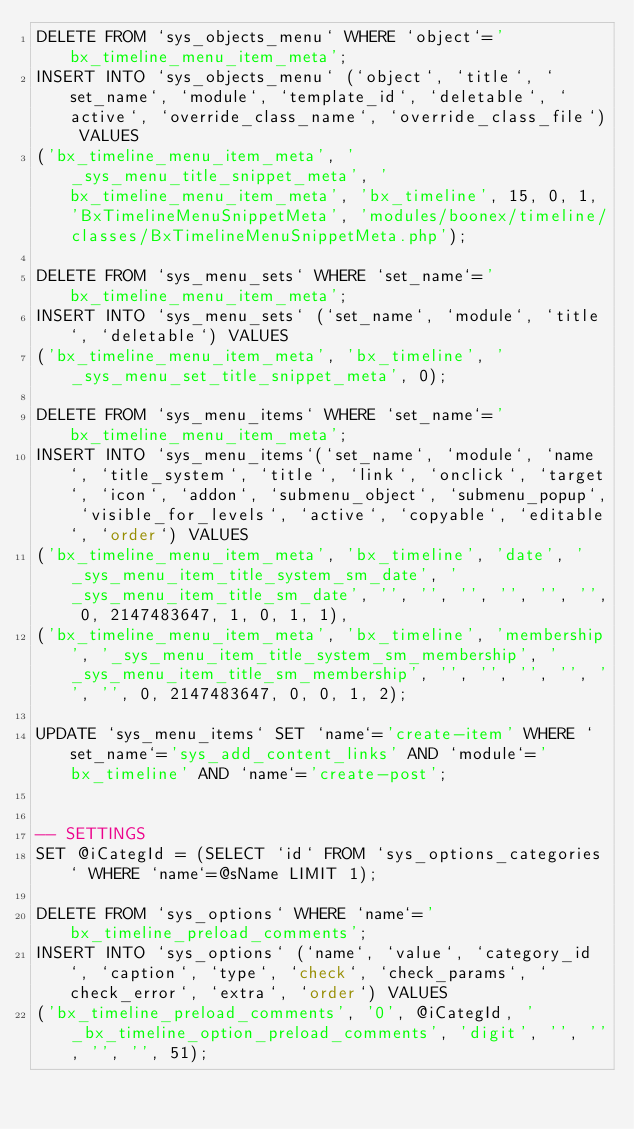Convert code to text. <code><loc_0><loc_0><loc_500><loc_500><_SQL_>DELETE FROM `sys_objects_menu` WHERE `object`='bx_timeline_menu_item_meta';
INSERT INTO `sys_objects_menu` (`object`, `title`, `set_name`, `module`, `template_id`, `deletable`, `active`, `override_class_name`, `override_class_file`) VALUES
('bx_timeline_menu_item_meta', '_sys_menu_title_snippet_meta', 'bx_timeline_menu_item_meta', 'bx_timeline', 15, 0, 1, 'BxTimelineMenuSnippetMeta', 'modules/boonex/timeline/classes/BxTimelineMenuSnippetMeta.php');

DELETE FROM `sys_menu_sets` WHERE `set_name`='bx_timeline_menu_item_meta';
INSERT INTO `sys_menu_sets` (`set_name`, `module`, `title`, `deletable`) VALUES
('bx_timeline_menu_item_meta', 'bx_timeline', '_sys_menu_set_title_snippet_meta', 0);

DELETE FROM `sys_menu_items` WHERE `set_name`='bx_timeline_menu_item_meta';
INSERT INTO `sys_menu_items`(`set_name`, `module`, `name`, `title_system`, `title`, `link`, `onclick`, `target`, `icon`, `addon`, `submenu_object`, `submenu_popup`, `visible_for_levels`, `active`, `copyable`, `editable`, `order`) VALUES 
('bx_timeline_menu_item_meta', 'bx_timeline', 'date', '_sys_menu_item_title_system_sm_date', '_sys_menu_item_title_sm_date', '', '', '', '', '', '', 0, 2147483647, 1, 0, 1, 1),
('bx_timeline_menu_item_meta', 'bx_timeline', 'membership', '_sys_menu_item_title_system_sm_membership', '_sys_menu_item_title_sm_membership', '', '', '', '', '', '', 0, 2147483647, 0, 0, 1, 2);

UPDATE `sys_menu_items` SET `name`='create-item' WHERE `set_name`='sys_add_content_links' AND `module`='bx_timeline' AND `name`='create-post';


-- SETTINGS
SET @iCategId = (SELECT `id` FROM `sys_options_categories` WHERE `name`=@sName LIMIT 1);

DELETE FROM `sys_options` WHERE `name`='bx_timeline_preload_comments';
INSERT INTO `sys_options` (`name`, `value`, `category_id`, `caption`, `type`, `check`, `check_params`, `check_error`, `extra`, `order`) VALUES
('bx_timeline_preload_comments', '0', @iCategId, '_bx_timeline_option_preload_comments', 'digit', '', '', '', '', 51);
</code> 